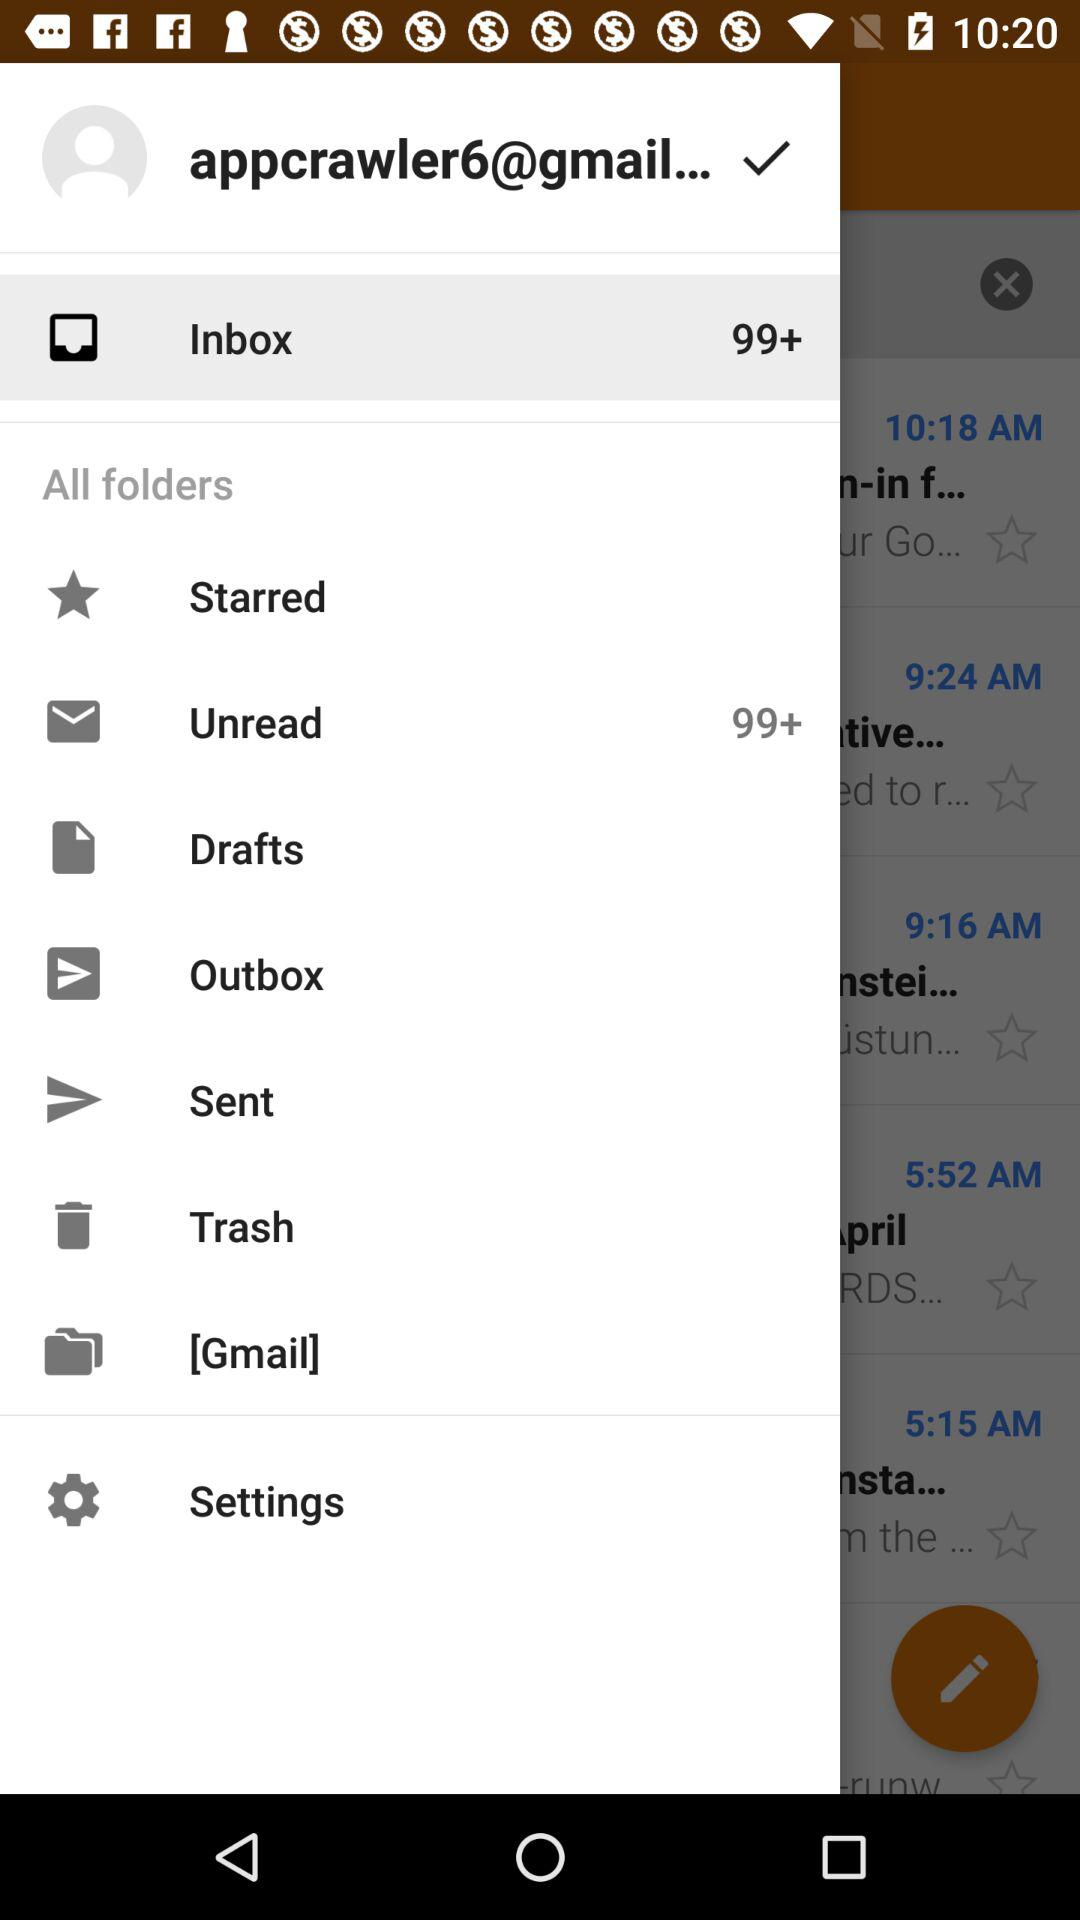What is the email address? The email address is "appcrawler6@gmail...". 